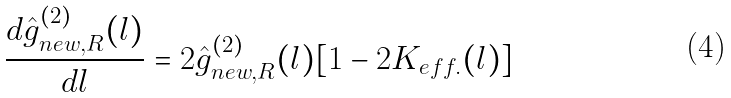<formula> <loc_0><loc_0><loc_500><loc_500>\frac { d \hat { g } ^ { ( 2 ) } _ { n e w , R } ( l ) } { d l } = 2 \hat { g } ^ { ( 2 ) } _ { n e w , R } ( l ) [ 1 - 2 K _ { e f f . } ( l ) ]</formula> 